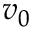Convert formula to latex. <formula><loc_0><loc_0><loc_500><loc_500>v _ { 0 }</formula> 